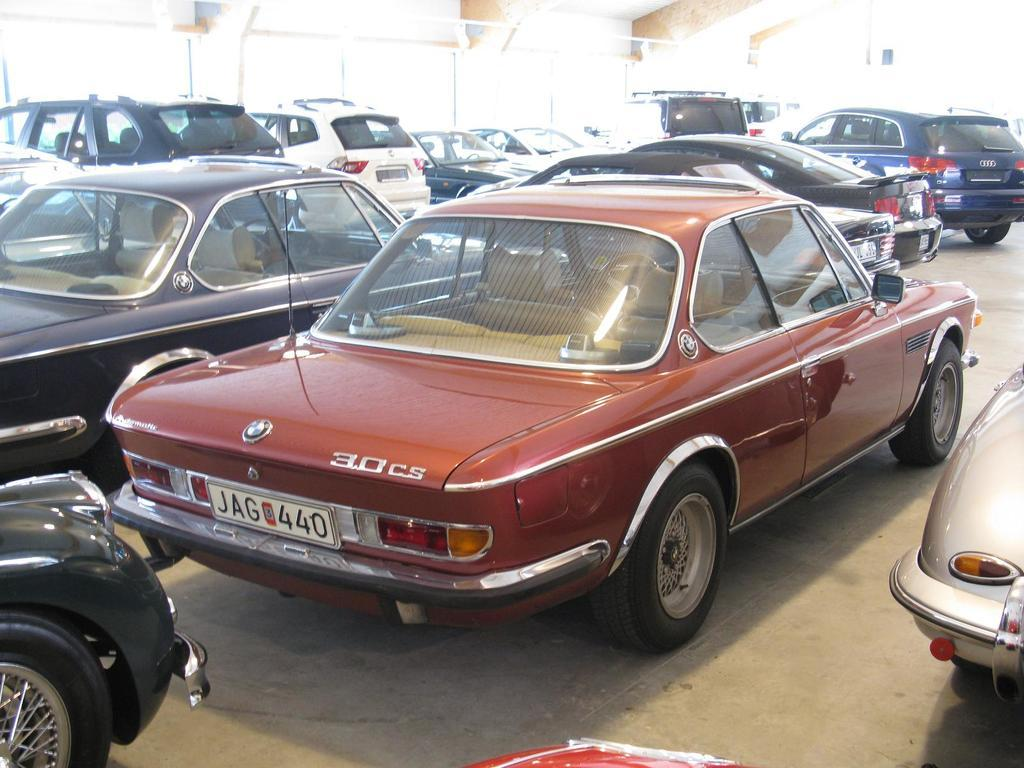What is the main subject of the image? The main subject of the image is a group of cars. What can be seen in the background of the image? There are glass doors in the background of the image. What is visible at the top of the image? The ceiling is visible at the top of the image. What is visible at the bottom of the image? The floor is visible at the bottom of the image. What month is it in the image? The month cannot be determined from the image, as there is no information about the time or date. 